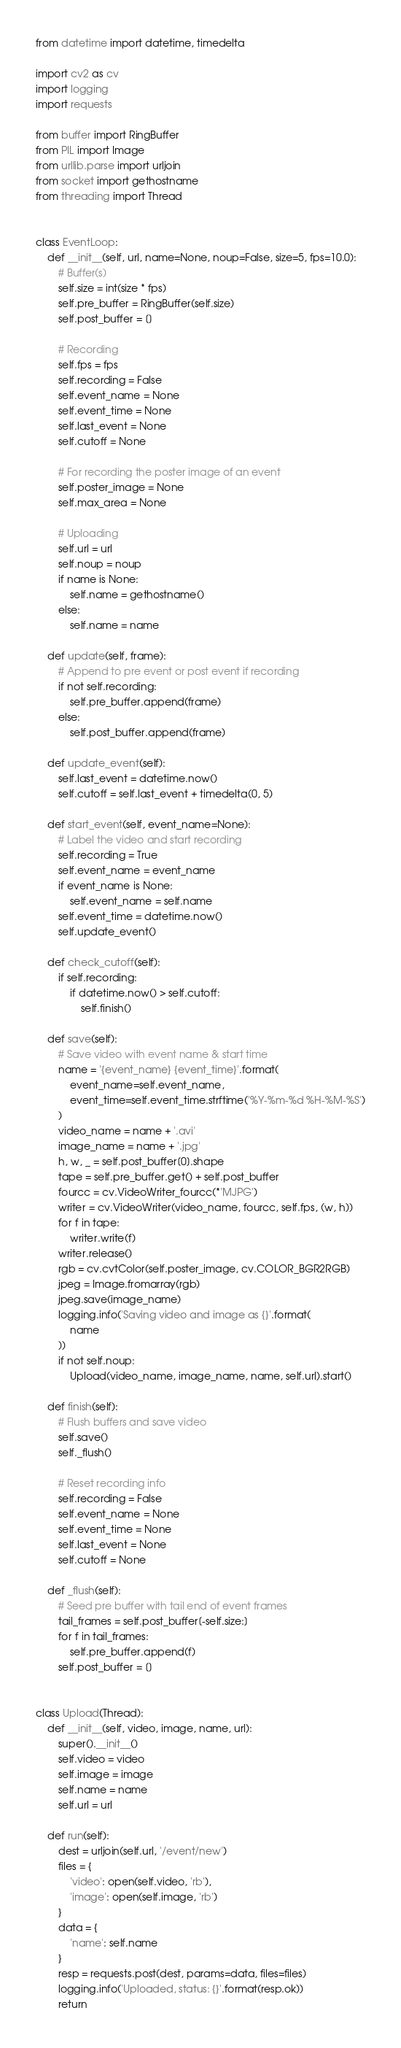<code> <loc_0><loc_0><loc_500><loc_500><_Python_>from datetime import datetime, timedelta

import cv2 as cv
import logging
import requests

from buffer import RingBuffer
from PIL import Image
from urllib.parse import urljoin
from socket import gethostname
from threading import Thread


class EventLoop:
    def __init__(self, url, name=None, noup=False, size=5, fps=10.0):
        # Buffer(s)
        self.size = int(size * fps)
        self.pre_buffer = RingBuffer(self.size)
        self.post_buffer = []

        # Recording
        self.fps = fps
        self.recording = False
        self.event_name = None
        self.event_time = None
        self.last_event = None
        self.cutoff = None

        # For recording the poster image of an event
        self.poster_image = None
        self.max_area = None

        # Uploading
        self.url = url
        self.noup = noup
        if name is None:
            self.name = gethostname()
        else:
            self.name = name

    def update(self, frame):
        # Append to pre event or post event if recording
        if not self.recording:
            self.pre_buffer.append(frame)
        else:
            self.post_buffer.append(frame)

    def update_event(self):
        self.last_event = datetime.now()
        self.cutoff = self.last_event + timedelta(0, 5)

    def start_event(self, event_name=None):
        # Label the video and start recording
        self.recording = True
        self.event_name = event_name
        if event_name is None:
            self.event_name = self.name
        self.event_time = datetime.now()
        self.update_event()

    def check_cutoff(self):
        if self.recording:
            if datetime.now() > self.cutoff:
                self.finish()

    def save(self):
        # Save video with event name & start time
        name = '{event_name} {event_time}'.format(
            event_name=self.event_name,
            event_time=self.event_time.strftime('%Y-%m-%d %H-%M-%S')
        )
        video_name = name + '.avi'
        image_name = name + '.jpg'
        h, w, _ = self.post_buffer[0].shape
        tape = self.pre_buffer.get() + self.post_buffer
        fourcc = cv.VideoWriter_fourcc(*'MJPG')
        writer = cv.VideoWriter(video_name, fourcc, self.fps, (w, h))
        for f in tape:
            writer.write(f)
        writer.release()
        rgb = cv.cvtColor(self.poster_image, cv.COLOR_BGR2RGB)
        jpeg = Image.fromarray(rgb)
        jpeg.save(image_name)
        logging.info('Saving video and image as {}'.format(
            name
        ))
        if not self.noup:
            Upload(video_name, image_name, name, self.url).start()

    def finish(self):
        # Flush buffers and save video
        self.save()
        self._flush()

        # Reset recording info
        self.recording = False
        self.event_name = None
        self.event_time = None
        self.last_event = None
        self.cutoff = None

    def _flush(self):
        # Seed pre buffer with tail end of event frames
        tail_frames = self.post_buffer[-self.size:]
        for f in tail_frames:
            self.pre_buffer.append(f)
        self.post_buffer = []


class Upload(Thread):
    def __init__(self, video, image, name, url):
        super().__init__()
        self.video = video
        self.image = image
        self.name = name
        self.url = url

    def run(self):
        dest = urljoin(self.url, '/event/new')
        files = {
            'video': open(self.video, 'rb'),
            'image': open(self.image, 'rb')
        }
        data = {
            'name': self.name
        }
        resp = requests.post(dest, params=data, files=files)
        logging.info('Uploaded, status: {}'.format(resp.ok))
        return
</code> 